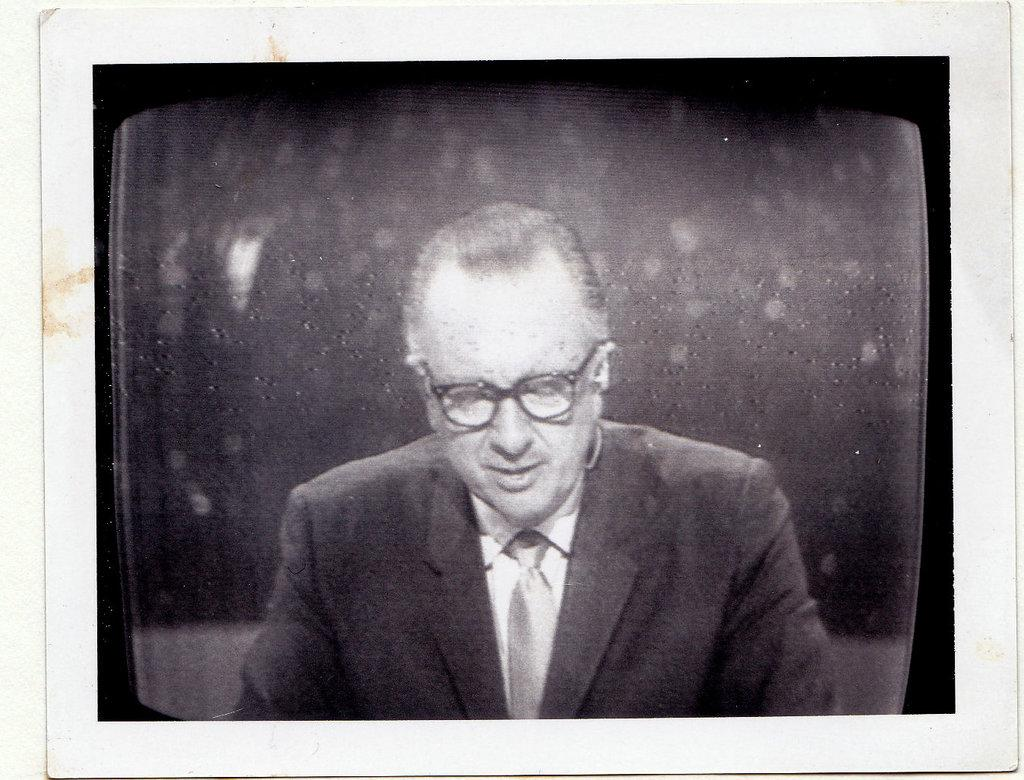What is depicted on the poster in the image? There is a poster in the image, and it features a person. What is the person wearing in the poster? The person is wearing a suit and spectacles in the poster. How many pizzas are being delivered by the person in the poster? There are no pizzas or delivery mentioned in the image; the poster features a person wearing a suit and spectacles. What type of coal is being used to heat the room in the image? There is no mention of coal or heating in the image; it only features a poster with a person wearing a suit and spectacles. 